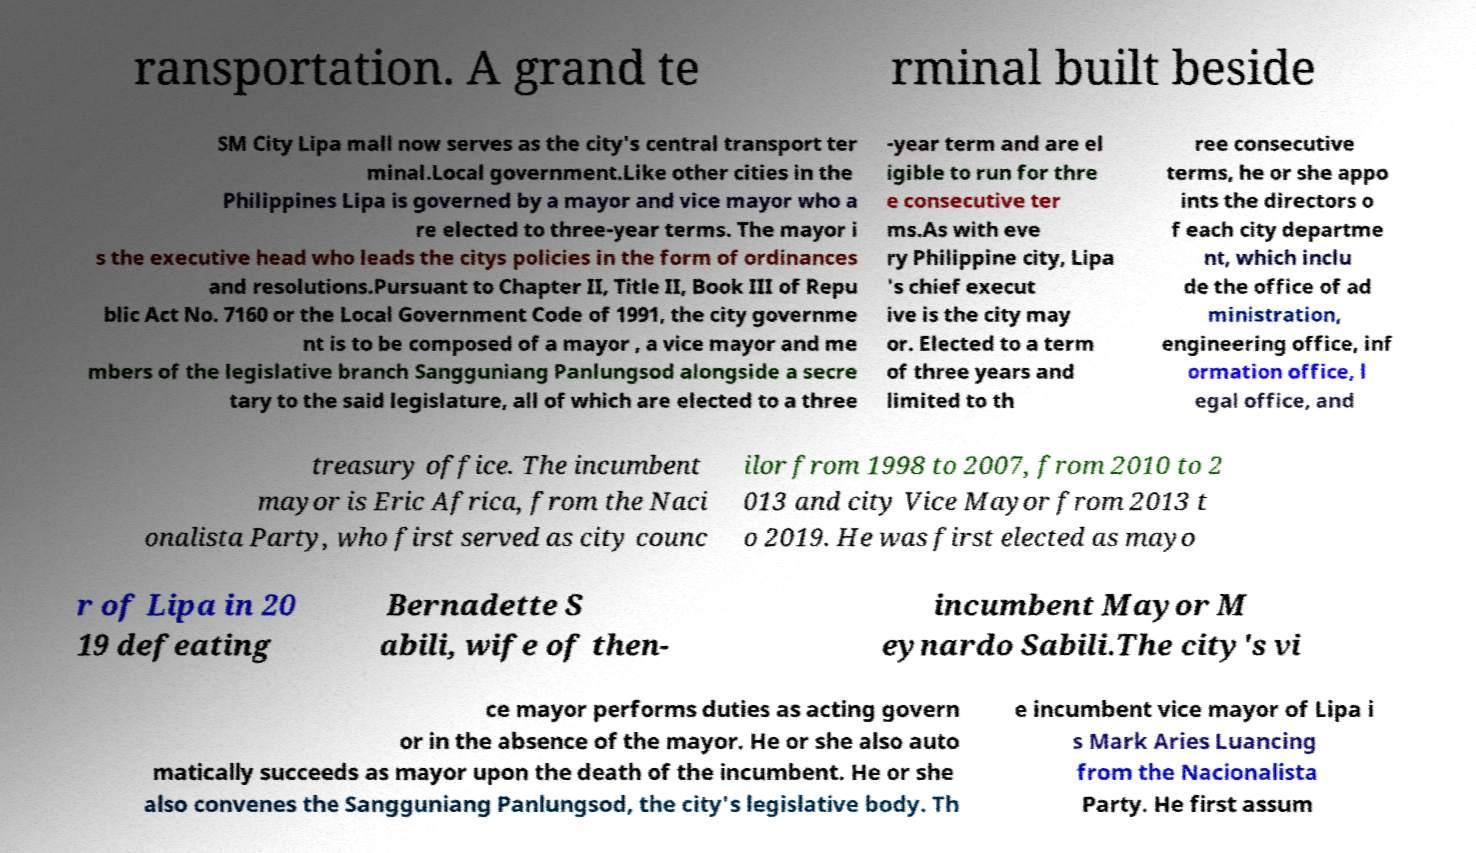Could you assist in decoding the text presented in this image and type it out clearly? ransportation. A grand te rminal built beside SM City Lipa mall now serves as the city's central transport ter minal.Local government.Like other cities in the Philippines Lipa is governed by a mayor and vice mayor who a re elected to three-year terms. The mayor i s the executive head who leads the citys policies in the form of ordinances and resolutions.Pursuant to Chapter II, Title II, Book III of Repu blic Act No. 7160 or the Local Government Code of 1991, the city governme nt is to be composed of a mayor , a vice mayor and me mbers of the legislative branch Sangguniang Panlungsod alongside a secre tary to the said legislature, all of which are elected to a three -year term and are el igible to run for thre e consecutive ter ms.As with eve ry Philippine city, Lipa 's chief execut ive is the city may or. Elected to a term of three years and limited to th ree consecutive terms, he or she appo ints the directors o f each city departme nt, which inclu de the office of ad ministration, engineering office, inf ormation office, l egal office, and treasury office. The incumbent mayor is Eric Africa, from the Naci onalista Party, who first served as city counc ilor from 1998 to 2007, from 2010 to 2 013 and city Vice Mayor from 2013 t o 2019. He was first elected as mayo r of Lipa in 20 19 defeating Bernadette S abili, wife of then- incumbent Mayor M eynardo Sabili.The city's vi ce mayor performs duties as acting govern or in the absence of the mayor. He or she also auto matically succeeds as mayor upon the death of the incumbent. He or she also convenes the Sangguniang Panlungsod, the city's legislative body. Th e incumbent vice mayor of Lipa i s Mark Aries Luancing from the Nacionalista Party. He first assum 